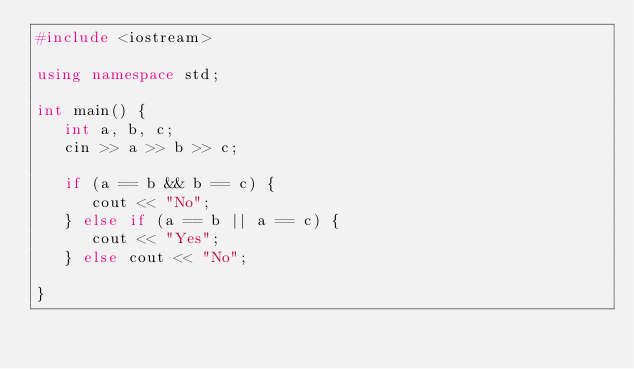Convert code to text. <code><loc_0><loc_0><loc_500><loc_500><_C++_>#include <iostream>

using namespace std;

int main() {
   int a, b, c;
   cin >> a >> b >> c;

   if (a == b && b == c) {
      cout << "No";
   } else if (a == b || a == c) {
      cout << "Yes";
   } else cout << "No";
   
}</code> 